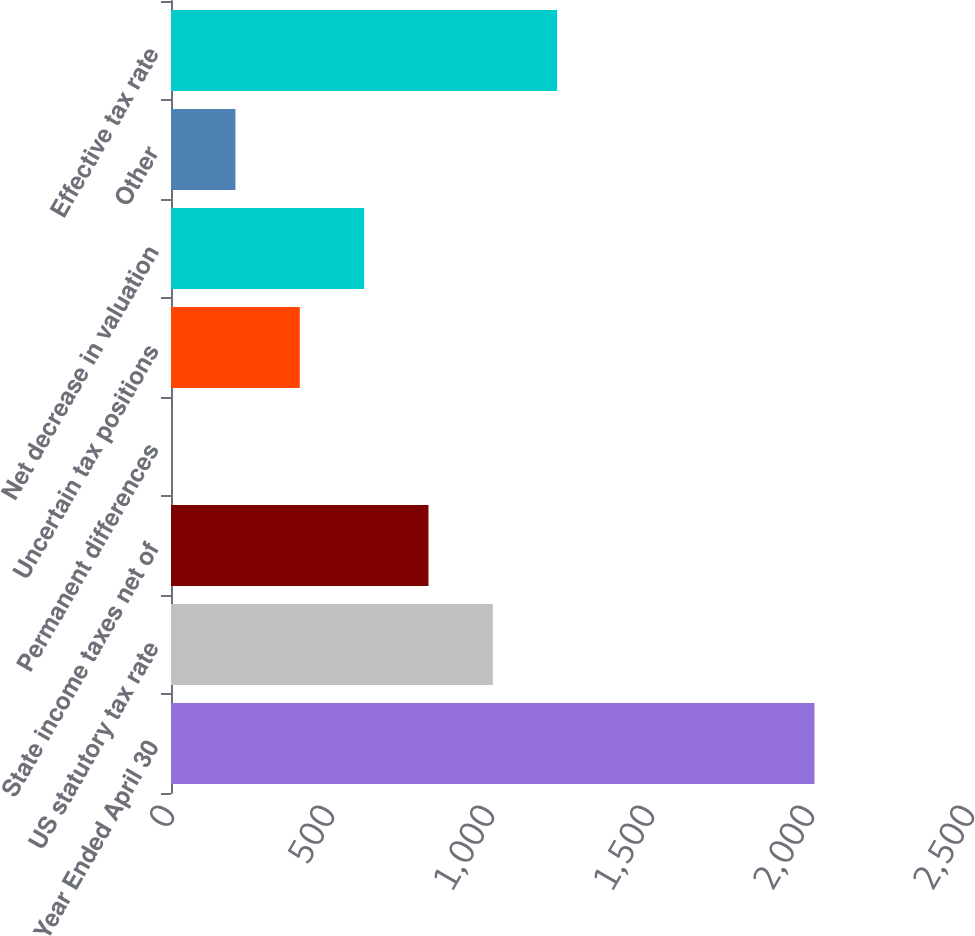Convert chart. <chart><loc_0><loc_0><loc_500><loc_500><bar_chart><fcel>Year Ended April 30<fcel>US statutory tax rate<fcel>State income taxes net of<fcel>Permanent differences<fcel>Uncertain tax positions<fcel>Net decrease in valuation<fcel>Other<fcel>Effective tax rate<nl><fcel>2011<fcel>1005.65<fcel>804.58<fcel>0.3<fcel>402.44<fcel>603.51<fcel>201.37<fcel>1206.72<nl></chart> 